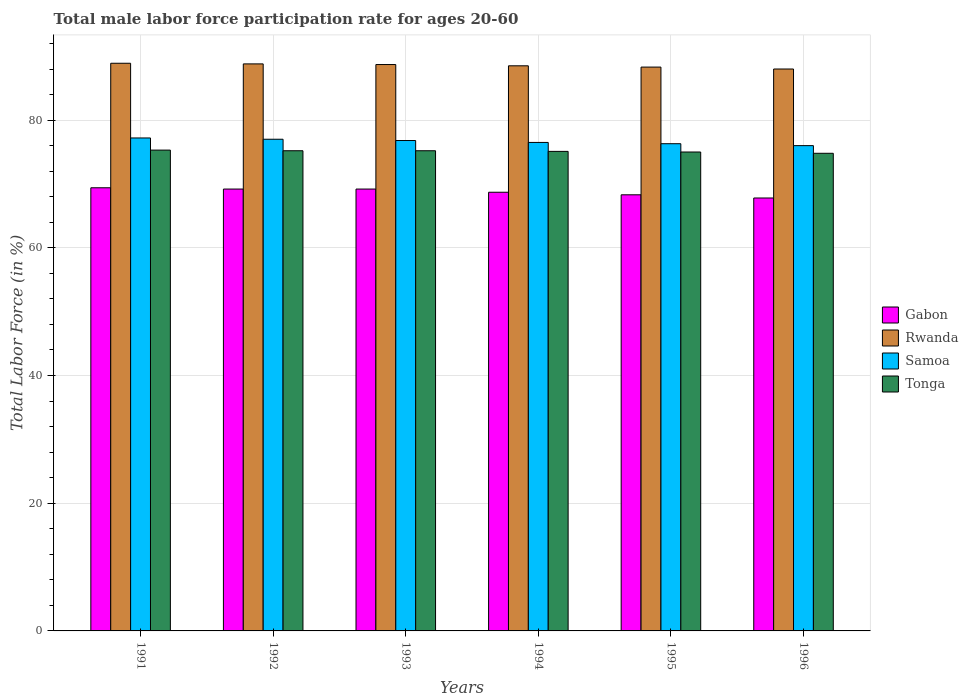How many groups of bars are there?
Your response must be concise. 6. How many bars are there on the 3rd tick from the right?
Provide a succinct answer. 4. In how many cases, is the number of bars for a given year not equal to the number of legend labels?
Provide a short and direct response. 0. What is the male labor force participation rate in Gabon in 1995?
Your response must be concise. 68.3. Across all years, what is the maximum male labor force participation rate in Gabon?
Your response must be concise. 69.4. What is the total male labor force participation rate in Samoa in the graph?
Give a very brief answer. 459.8. What is the difference between the male labor force participation rate in Rwanda in 1995 and that in 1996?
Your answer should be very brief. 0.3. What is the difference between the male labor force participation rate in Gabon in 1991 and the male labor force participation rate in Tonga in 1996?
Your answer should be very brief. -5.4. What is the average male labor force participation rate in Samoa per year?
Make the answer very short. 76.63. In the year 1993, what is the difference between the male labor force participation rate in Samoa and male labor force participation rate in Tonga?
Provide a short and direct response. 1.6. In how many years, is the male labor force participation rate in Samoa greater than 72 %?
Your answer should be very brief. 6. What is the ratio of the male labor force participation rate in Tonga in 1992 to that in 1994?
Keep it short and to the point. 1. Is the male labor force participation rate in Gabon in 1995 less than that in 1996?
Ensure brevity in your answer.  No. What is the difference between the highest and the second highest male labor force participation rate in Gabon?
Provide a succinct answer. 0.2. In how many years, is the male labor force participation rate in Rwanda greater than the average male labor force participation rate in Rwanda taken over all years?
Offer a terse response. 3. What does the 3rd bar from the left in 1995 represents?
Offer a very short reply. Samoa. What does the 4th bar from the right in 1993 represents?
Your response must be concise. Gabon. How many bars are there?
Your response must be concise. 24. Are all the bars in the graph horizontal?
Provide a succinct answer. No. Does the graph contain grids?
Your answer should be very brief. Yes. Where does the legend appear in the graph?
Give a very brief answer. Center right. How are the legend labels stacked?
Offer a terse response. Vertical. What is the title of the graph?
Your answer should be compact. Total male labor force participation rate for ages 20-60. Does "Afghanistan" appear as one of the legend labels in the graph?
Make the answer very short. No. What is the label or title of the X-axis?
Give a very brief answer. Years. What is the Total Labor Force (in %) of Gabon in 1991?
Your answer should be compact. 69.4. What is the Total Labor Force (in %) in Rwanda in 1991?
Make the answer very short. 88.9. What is the Total Labor Force (in %) of Samoa in 1991?
Keep it short and to the point. 77.2. What is the Total Labor Force (in %) in Tonga in 1991?
Offer a very short reply. 75.3. What is the Total Labor Force (in %) in Gabon in 1992?
Provide a short and direct response. 69.2. What is the Total Labor Force (in %) of Rwanda in 1992?
Keep it short and to the point. 88.8. What is the Total Labor Force (in %) in Samoa in 1992?
Provide a succinct answer. 77. What is the Total Labor Force (in %) in Tonga in 1992?
Offer a terse response. 75.2. What is the Total Labor Force (in %) of Gabon in 1993?
Your response must be concise. 69.2. What is the Total Labor Force (in %) in Rwanda in 1993?
Provide a succinct answer. 88.7. What is the Total Labor Force (in %) of Samoa in 1993?
Your answer should be compact. 76.8. What is the Total Labor Force (in %) in Tonga in 1993?
Ensure brevity in your answer.  75.2. What is the Total Labor Force (in %) of Gabon in 1994?
Your answer should be compact. 68.7. What is the Total Labor Force (in %) in Rwanda in 1994?
Keep it short and to the point. 88.5. What is the Total Labor Force (in %) of Samoa in 1994?
Provide a short and direct response. 76.5. What is the Total Labor Force (in %) of Tonga in 1994?
Your answer should be compact. 75.1. What is the Total Labor Force (in %) of Gabon in 1995?
Keep it short and to the point. 68.3. What is the Total Labor Force (in %) in Rwanda in 1995?
Your answer should be very brief. 88.3. What is the Total Labor Force (in %) in Samoa in 1995?
Your answer should be compact. 76.3. What is the Total Labor Force (in %) of Tonga in 1995?
Keep it short and to the point. 75. What is the Total Labor Force (in %) in Gabon in 1996?
Make the answer very short. 67.8. What is the Total Labor Force (in %) of Rwanda in 1996?
Offer a terse response. 88. What is the Total Labor Force (in %) of Samoa in 1996?
Your response must be concise. 76. What is the Total Labor Force (in %) in Tonga in 1996?
Provide a succinct answer. 74.8. Across all years, what is the maximum Total Labor Force (in %) in Gabon?
Your response must be concise. 69.4. Across all years, what is the maximum Total Labor Force (in %) in Rwanda?
Provide a short and direct response. 88.9. Across all years, what is the maximum Total Labor Force (in %) in Samoa?
Your answer should be compact. 77.2. Across all years, what is the maximum Total Labor Force (in %) of Tonga?
Keep it short and to the point. 75.3. Across all years, what is the minimum Total Labor Force (in %) in Gabon?
Make the answer very short. 67.8. Across all years, what is the minimum Total Labor Force (in %) of Tonga?
Your response must be concise. 74.8. What is the total Total Labor Force (in %) in Gabon in the graph?
Ensure brevity in your answer.  412.6. What is the total Total Labor Force (in %) in Rwanda in the graph?
Your answer should be compact. 531.2. What is the total Total Labor Force (in %) in Samoa in the graph?
Keep it short and to the point. 459.8. What is the total Total Labor Force (in %) in Tonga in the graph?
Give a very brief answer. 450.6. What is the difference between the Total Labor Force (in %) of Gabon in 1991 and that in 1992?
Provide a succinct answer. 0.2. What is the difference between the Total Labor Force (in %) of Rwanda in 1991 and that in 1992?
Make the answer very short. 0.1. What is the difference between the Total Labor Force (in %) in Samoa in 1991 and that in 1992?
Your answer should be very brief. 0.2. What is the difference between the Total Labor Force (in %) in Samoa in 1991 and that in 1993?
Give a very brief answer. 0.4. What is the difference between the Total Labor Force (in %) of Samoa in 1991 and that in 1994?
Ensure brevity in your answer.  0.7. What is the difference between the Total Labor Force (in %) of Gabon in 1991 and that in 1995?
Your answer should be compact. 1.1. What is the difference between the Total Labor Force (in %) in Samoa in 1991 and that in 1995?
Ensure brevity in your answer.  0.9. What is the difference between the Total Labor Force (in %) of Tonga in 1991 and that in 1995?
Ensure brevity in your answer.  0.3. What is the difference between the Total Labor Force (in %) of Gabon in 1991 and that in 1996?
Your response must be concise. 1.6. What is the difference between the Total Labor Force (in %) in Rwanda in 1991 and that in 1996?
Offer a very short reply. 0.9. What is the difference between the Total Labor Force (in %) in Samoa in 1991 and that in 1996?
Provide a succinct answer. 1.2. What is the difference between the Total Labor Force (in %) in Gabon in 1992 and that in 1993?
Offer a very short reply. 0. What is the difference between the Total Labor Force (in %) of Samoa in 1992 and that in 1993?
Ensure brevity in your answer.  0.2. What is the difference between the Total Labor Force (in %) of Rwanda in 1992 and that in 1994?
Offer a very short reply. 0.3. What is the difference between the Total Labor Force (in %) of Tonga in 1992 and that in 1994?
Make the answer very short. 0.1. What is the difference between the Total Labor Force (in %) in Gabon in 1992 and that in 1995?
Keep it short and to the point. 0.9. What is the difference between the Total Labor Force (in %) of Rwanda in 1992 and that in 1995?
Give a very brief answer. 0.5. What is the difference between the Total Labor Force (in %) in Tonga in 1992 and that in 1995?
Make the answer very short. 0.2. What is the difference between the Total Labor Force (in %) of Rwanda in 1992 and that in 1996?
Offer a very short reply. 0.8. What is the difference between the Total Labor Force (in %) of Tonga in 1992 and that in 1996?
Your answer should be compact. 0.4. What is the difference between the Total Labor Force (in %) in Gabon in 1993 and that in 1994?
Your answer should be very brief. 0.5. What is the difference between the Total Labor Force (in %) in Gabon in 1993 and that in 1995?
Offer a terse response. 0.9. What is the difference between the Total Labor Force (in %) of Rwanda in 1993 and that in 1995?
Ensure brevity in your answer.  0.4. What is the difference between the Total Labor Force (in %) in Samoa in 1993 and that in 1995?
Ensure brevity in your answer.  0.5. What is the difference between the Total Labor Force (in %) in Tonga in 1993 and that in 1995?
Your answer should be very brief. 0.2. What is the difference between the Total Labor Force (in %) in Samoa in 1993 and that in 1996?
Make the answer very short. 0.8. What is the difference between the Total Labor Force (in %) of Tonga in 1993 and that in 1996?
Keep it short and to the point. 0.4. What is the difference between the Total Labor Force (in %) of Gabon in 1994 and that in 1995?
Ensure brevity in your answer.  0.4. What is the difference between the Total Labor Force (in %) of Samoa in 1994 and that in 1995?
Your answer should be very brief. 0.2. What is the difference between the Total Labor Force (in %) in Tonga in 1994 and that in 1995?
Ensure brevity in your answer.  0.1. What is the difference between the Total Labor Force (in %) of Samoa in 1994 and that in 1996?
Make the answer very short. 0.5. What is the difference between the Total Labor Force (in %) in Tonga in 1994 and that in 1996?
Your answer should be very brief. 0.3. What is the difference between the Total Labor Force (in %) of Gabon in 1995 and that in 1996?
Ensure brevity in your answer.  0.5. What is the difference between the Total Labor Force (in %) in Rwanda in 1995 and that in 1996?
Provide a succinct answer. 0.3. What is the difference between the Total Labor Force (in %) in Samoa in 1995 and that in 1996?
Your answer should be compact. 0.3. What is the difference between the Total Labor Force (in %) in Tonga in 1995 and that in 1996?
Keep it short and to the point. 0.2. What is the difference between the Total Labor Force (in %) of Gabon in 1991 and the Total Labor Force (in %) of Rwanda in 1992?
Provide a succinct answer. -19.4. What is the difference between the Total Labor Force (in %) of Rwanda in 1991 and the Total Labor Force (in %) of Tonga in 1992?
Your response must be concise. 13.7. What is the difference between the Total Labor Force (in %) of Gabon in 1991 and the Total Labor Force (in %) of Rwanda in 1993?
Your answer should be compact. -19.3. What is the difference between the Total Labor Force (in %) in Gabon in 1991 and the Total Labor Force (in %) in Tonga in 1993?
Provide a short and direct response. -5.8. What is the difference between the Total Labor Force (in %) of Rwanda in 1991 and the Total Labor Force (in %) of Tonga in 1993?
Provide a short and direct response. 13.7. What is the difference between the Total Labor Force (in %) of Samoa in 1991 and the Total Labor Force (in %) of Tonga in 1993?
Make the answer very short. 2. What is the difference between the Total Labor Force (in %) of Gabon in 1991 and the Total Labor Force (in %) of Rwanda in 1994?
Offer a very short reply. -19.1. What is the difference between the Total Labor Force (in %) in Rwanda in 1991 and the Total Labor Force (in %) in Samoa in 1994?
Keep it short and to the point. 12.4. What is the difference between the Total Labor Force (in %) of Gabon in 1991 and the Total Labor Force (in %) of Rwanda in 1995?
Offer a terse response. -18.9. What is the difference between the Total Labor Force (in %) of Gabon in 1991 and the Total Labor Force (in %) of Samoa in 1995?
Give a very brief answer. -6.9. What is the difference between the Total Labor Force (in %) in Gabon in 1991 and the Total Labor Force (in %) in Rwanda in 1996?
Keep it short and to the point. -18.6. What is the difference between the Total Labor Force (in %) in Gabon in 1991 and the Total Labor Force (in %) in Tonga in 1996?
Offer a terse response. -5.4. What is the difference between the Total Labor Force (in %) of Gabon in 1992 and the Total Labor Force (in %) of Rwanda in 1993?
Offer a terse response. -19.5. What is the difference between the Total Labor Force (in %) in Gabon in 1992 and the Total Labor Force (in %) in Rwanda in 1994?
Make the answer very short. -19.3. What is the difference between the Total Labor Force (in %) in Gabon in 1992 and the Total Labor Force (in %) in Samoa in 1994?
Give a very brief answer. -7.3. What is the difference between the Total Labor Force (in %) in Rwanda in 1992 and the Total Labor Force (in %) in Samoa in 1994?
Offer a very short reply. 12.3. What is the difference between the Total Labor Force (in %) of Gabon in 1992 and the Total Labor Force (in %) of Rwanda in 1995?
Your answer should be very brief. -19.1. What is the difference between the Total Labor Force (in %) of Gabon in 1992 and the Total Labor Force (in %) of Tonga in 1995?
Offer a terse response. -5.8. What is the difference between the Total Labor Force (in %) in Rwanda in 1992 and the Total Labor Force (in %) in Tonga in 1995?
Make the answer very short. 13.8. What is the difference between the Total Labor Force (in %) in Samoa in 1992 and the Total Labor Force (in %) in Tonga in 1995?
Give a very brief answer. 2. What is the difference between the Total Labor Force (in %) in Gabon in 1992 and the Total Labor Force (in %) in Rwanda in 1996?
Offer a terse response. -18.8. What is the difference between the Total Labor Force (in %) of Gabon in 1992 and the Total Labor Force (in %) of Samoa in 1996?
Your answer should be very brief. -6.8. What is the difference between the Total Labor Force (in %) of Gabon in 1992 and the Total Labor Force (in %) of Tonga in 1996?
Make the answer very short. -5.6. What is the difference between the Total Labor Force (in %) of Rwanda in 1992 and the Total Labor Force (in %) of Tonga in 1996?
Your answer should be very brief. 14. What is the difference between the Total Labor Force (in %) of Gabon in 1993 and the Total Labor Force (in %) of Rwanda in 1994?
Offer a very short reply. -19.3. What is the difference between the Total Labor Force (in %) of Gabon in 1993 and the Total Labor Force (in %) of Rwanda in 1995?
Your answer should be very brief. -19.1. What is the difference between the Total Labor Force (in %) in Rwanda in 1993 and the Total Labor Force (in %) in Samoa in 1995?
Ensure brevity in your answer.  12.4. What is the difference between the Total Labor Force (in %) in Rwanda in 1993 and the Total Labor Force (in %) in Tonga in 1995?
Your answer should be compact. 13.7. What is the difference between the Total Labor Force (in %) of Gabon in 1993 and the Total Labor Force (in %) of Rwanda in 1996?
Your answer should be very brief. -18.8. What is the difference between the Total Labor Force (in %) in Rwanda in 1993 and the Total Labor Force (in %) in Samoa in 1996?
Your response must be concise. 12.7. What is the difference between the Total Labor Force (in %) of Rwanda in 1993 and the Total Labor Force (in %) of Tonga in 1996?
Give a very brief answer. 13.9. What is the difference between the Total Labor Force (in %) of Gabon in 1994 and the Total Labor Force (in %) of Rwanda in 1995?
Provide a succinct answer. -19.6. What is the difference between the Total Labor Force (in %) of Samoa in 1994 and the Total Labor Force (in %) of Tonga in 1995?
Make the answer very short. 1.5. What is the difference between the Total Labor Force (in %) of Gabon in 1994 and the Total Labor Force (in %) of Rwanda in 1996?
Keep it short and to the point. -19.3. What is the difference between the Total Labor Force (in %) of Gabon in 1994 and the Total Labor Force (in %) of Samoa in 1996?
Provide a succinct answer. -7.3. What is the difference between the Total Labor Force (in %) of Gabon in 1994 and the Total Labor Force (in %) of Tonga in 1996?
Your response must be concise. -6.1. What is the difference between the Total Labor Force (in %) of Rwanda in 1994 and the Total Labor Force (in %) of Tonga in 1996?
Keep it short and to the point. 13.7. What is the difference between the Total Labor Force (in %) of Gabon in 1995 and the Total Labor Force (in %) of Rwanda in 1996?
Your answer should be compact. -19.7. What is the difference between the Total Labor Force (in %) of Gabon in 1995 and the Total Labor Force (in %) of Tonga in 1996?
Give a very brief answer. -6.5. What is the difference between the Total Labor Force (in %) of Rwanda in 1995 and the Total Labor Force (in %) of Samoa in 1996?
Provide a succinct answer. 12.3. What is the difference between the Total Labor Force (in %) in Samoa in 1995 and the Total Labor Force (in %) in Tonga in 1996?
Your answer should be very brief. 1.5. What is the average Total Labor Force (in %) in Gabon per year?
Offer a very short reply. 68.77. What is the average Total Labor Force (in %) of Rwanda per year?
Offer a terse response. 88.53. What is the average Total Labor Force (in %) of Samoa per year?
Offer a terse response. 76.63. What is the average Total Labor Force (in %) in Tonga per year?
Keep it short and to the point. 75.1. In the year 1991, what is the difference between the Total Labor Force (in %) of Gabon and Total Labor Force (in %) of Rwanda?
Offer a very short reply. -19.5. In the year 1991, what is the difference between the Total Labor Force (in %) in Gabon and Total Labor Force (in %) in Samoa?
Make the answer very short. -7.8. In the year 1991, what is the difference between the Total Labor Force (in %) in Gabon and Total Labor Force (in %) in Tonga?
Provide a short and direct response. -5.9. In the year 1991, what is the difference between the Total Labor Force (in %) in Rwanda and Total Labor Force (in %) in Samoa?
Your answer should be very brief. 11.7. In the year 1991, what is the difference between the Total Labor Force (in %) of Rwanda and Total Labor Force (in %) of Tonga?
Your response must be concise. 13.6. In the year 1991, what is the difference between the Total Labor Force (in %) in Samoa and Total Labor Force (in %) in Tonga?
Give a very brief answer. 1.9. In the year 1992, what is the difference between the Total Labor Force (in %) in Gabon and Total Labor Force (in %) in Rwanda?
Offer a terse response. -19.6. In the year 1992, what is the difference between the Total Labor Force (in %) in Rwanda and Total Labor Force (in %) in Samoa?
Your answer should be very brief. 11.8. In the year 1992, what is the difference between the Total Labor Force (in %) of Rwanda and Total Labor Force (in %) of Tonga?
Give a very brief answer. 13.6. In the year 1993, what is the difference between the Total Labor Force (in %) in Gabon and Total Labor Force (in %) in Rwanda?
Offer a very short reply. -19.5. In the year 1993, what is the difference between the Total Labor Force (in %) in Gabon and Total Labor Force (in %) in Samoa?
Keep it short and to the point. -7.6. In the year 1993, what is the difference between the Total Labor Force (in %) in Rwanda and Total Labor Force (in %) in Samoa?
Ensure brevity in your answer.  11.9. In the year 1993, what is the difference between the Total Labor Force (in %) in Samoa and Total Labor Force (in %) in Tonga?
Provide a succinct answer. 1.6. In the year 1994, what is the difference between the Total Labor Force (in %) of Gabon and Total Labor Force (in %) of Rwanda?
Make the answer very short. -19.8. In the year 1994, what is the difference between the Total Labor Force (in %) in Gabon and Total Labor Force (in %) in Samoa?
Provide a succinct answer. -7.8. In the year 1994, what is the difference between the Total Labor Force (in %) of Rwanda and Total Labor Force (in %) of Tonga?
Offer a terse response. 13.4. In the year 1994, what is the difference between the Total Labor Force (in %) of Samoa and Total Labor Force (in %) of Tonga?
Your answer should be very brief. 1.4. In the year 1995, what is the difference between the Total Labor Force (in %) in Gabon and Total Labor Force (in %) in Tonga?
Your response must be concise. -6.7. In the year 1995, what is the difference between the Total Labor Force (in %) of Rwanda and Total Labor Force (in %) of Tonga?
Your answer should be compact. 13.3. In the year 1996, what is the difference between the Total Labor Force (in %) in Gabon and Total Labor Force (in %) in Rwanda?
Give a very brief answer. -20.2. In the year 1996, what is the difference between the Total Labor Force (in %) of Gabon and Total Labor Force (in %) of Samoa?
Provide a short and direct response. -8.2. What is the ratio of the Total Labor Force (in %) in Rwanda in 1991 to that in 1992?
Your answer should be compact. 1. What is the ratio of the Total Labor Force (in %) of Tonga in 1991 to that in 1992?
Keep it short and to the point. 1. What is the ratio of the Total Labor Force (in %) of Gabon in 1991 to that in 1993?
Keep it short and to the point. 1. What is the ratio of the Total Labor Force (in %) in Rwanda in 1991 to that in 1993?
Offer a very short reply. 1. What is the ratio of the Total Labor Force (in %) of Samoa in 1991 to that in 1993?
Make the answer very short. 1.01. What is the ratio of the Total Labor Force (in %) of Tonga in 1991 to that in 1993?
Make the answer very short. 1. What is the ratio of the Total Labor Force (in %) in Gabon in 1991 to that in 1994?
Keep it short and to the point. 1.01. What is the ratio of the Total Labor Force (in %) in Samoa in 1991 to that in 1994?
Provide a short and direct response. 1.01. What is the ratio of the Total Labor Force (in %) of Gabon in 1991 to that in 1995?
Provide a succinct answer. 1.02. What is the ratio of the Total Labor Force (in %) in Rwanda in 1991 to that in 1995?
Ensure brevity in your answer.  1.01. What is the ratio of the Total Labor Force (in %) in Samoa in 1991 to that in 1995?
Give a very brief answer. 1.01. What is the ratio of the Total Labor Force (in %) of Gabon in 1991 to that in 1996?
Your response must be concise. 1.02. What is the ratio of the Total Labor Force (in %) in Rwanda in 1991 to that in 1996?
Your answer should be compact. 1.01. What is the ratio of the Total Labor Force (in %) of Samoa in 1991 to that in 1996?
Your answer should be very brief. 1.02. What is the ratio of the Total Labor Force (in %) of Gabon in 1992 to that in 1993?
Make the answer very short. 1. What is the ratio of the Total Labor Force (in %) of Rwanda in 1992 to that in 1993?
Your answer should be very brief. 1. What is the ratio of the Total Labor Force (in %) in Samoa in 1992 to that in 1993?
Make the answer very short. 1. What is the ratio of the Total Labor Force (in %) in Tonga in 1992 to that in 1993?
Ensure brevity in your answer.  1. What is the ratio of the Total Labor Force (in %) of Gabon in 1992 to that in 1994?
Provide a succinct answer. 1.01. What is the ratio of the Total Labor Force (in %) in Samoa in 1992 to that in 1994?
Offer a very short reply. 1.01. What is the ratio of the Total Labor Force (in %) in Gabon in 1992 to that in 1995?
Make the answer very short. 1.01. What is the ratio of the Total Labor Force (in %) in Samoa in 1992 to that in 1995?
Provide a short and direct response. 1.01. What is the ratio of the Total Labor Force (in %) of Tonga in 1992 to that in 1995?
Make the answer very short. 1. What is the ratio of the Total Labor Force (in %) in Gabon in 1992 to that in 1996?
Give a very brief answer. 1.02. What is the ratio of the Total Labor Force (in %) in Rwanda in 1992 to that in 1996?
Offer a terse response. 1.01. What is the ratio of the Total Labor Force (in %) in Samoa in 1992 to that in 1996?
Your answer should be very brief. 1.01. What is the ratio of the Total Labor Force (in %) in Gabon in 1993 to that in 1994?
Ensure brevity in your answer.  1.01. What is the ratio of the Total Labor Force (in %) of Rwanda in 1993 to that in 1994?
Offer a very short reply. 1. What is the ratio of the Total Labor Force (in %) of Gabon in 1993 to that in 1995?
Offer a terse response. 1.01. What is the ratio of the Total Labor Force (in %) of Samoa in 1993 to that in 1995?
Offer a terse response. 1.01. What is the ratio of the Total Labor Force (in %) in Tonga in 1993 to that in 1995?
Give a very brief answer. 1. What is the ratio of the Total Labor Force (in %) of Gabon in 1993 to that in 1996?
Keep it short and to the point. 1.02. What is the ratio of the Total Labor Force (in %) in Rwanda in 1993 to that in 1996?
Make the answer very short. 1.01. What is the ratio of the Total Labor Force (in %) in Samoa in 1993 to that in 1996?
Keep it short and to the point. 1.01. What is the ratio of the Total Labor Force (in %) in Gabon in 1994 to that in 1995?
Keep it short and to the point. 1.01. What is the ratio of the Total Labor Force (in %) of Samoa in 1994 to that in 1995?
Offer a very short reply. 1. What is the ratio of the Total Labor Force (in %) of Tonga in 1994 to that in 1995?
Keep it short and to the point. 1. What is the ratio of the Total Labor Force (in %) in Gabon in 1994 to that in 1996?
Your answer should be compact. 1.01. What is the ratio of the Total Labor Force (in %) of Rwanda in 1994 to that in 1996?
Ensure brevity in your answer.  1.01. What is the ratio of the Total Labor Force (in %) in Samoa in 1994 to that in 1996?
Your answer should be very brief. 1.01. What is the ratio of the Total Labor Force (in %) in Tonga in 1994 to that in 1996?
Make the answer very short. 1. What is the ratio of the Total Labor Force (in %) in Gabon in 1995 to that in 1996?
Your answer should be very brief. 1.01. What is the ratio of the Total Labor Force (in %) in Samoa in 1995 to that in 1996?
Your answer should be compact. 1. What is the difference between the highest and the lowest Total Labor Force (in %) of Gabon?
Provide a short and direct response. 1.6. What is the difference between the highest and the lowest Total Labor Force (in %) in Tonga?
Your answer should be very brief. 0.5. 